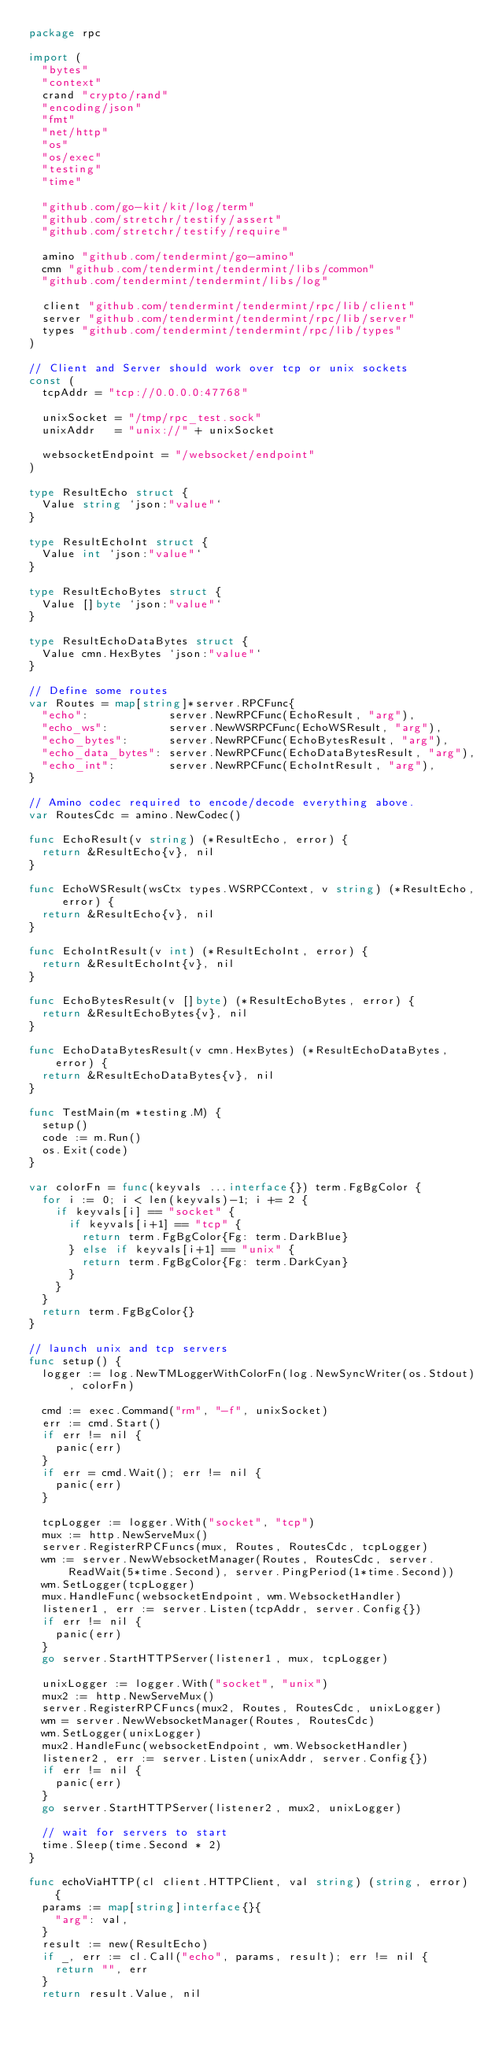<code> <loc_0><loc_0><loc_500><loc_500><_Go_>package rpc

import (
	"bytes"
	"context"
	crand "crypto/rand"
	"encoding/json"
	"fmt"
	"net/http"
	"os"
	"os/exec"
	"testing"
	"time"

	"github.com/go-kit/kit/log/term"
	"github.com/stretchr/testify/assert"
	"github.com/stretchr/testify/require"

	amino "github.com/tendermint/go-amino"
	cmn "github.com/tendermint/tendermint/libs/common"
	"github.com/tendermint/tendermint/libs/log"

	client "github.com/tendermint/tendermint/rpc/lib/client"
	server "github.com/tendermint/tendermint/rpc/lib/server"
	types "github.com/tendermint/tendermint/rpc/lib/types"
)

// Client and Server should work over tcp or unix sockets
const (
	tcpAddr = "tcp://0.0.0.0:47768"

	unixSocket = "/tmp/rpc_test.sock"
	unixAddr   = "unix://" + unixSocket

	websocketEndpoint = "/websocket/endpoint"
)

type ResultEcho struct {
	Value string `json:"value"`
}

type ResultEchoInt struct {
	Value int `json:"value"`
}

type ResultEchoBytes struct {
	Value []byte `json:"value"`
}

type ResultEchoDataBytes struct {
	Value cmn.HexBytes `json:"value"`
}

// Define some routes
var Routes = map[string]*server.RPCFunc{
	"echo":            server.NewRPCFunc(EchoResult, "arg"),
	"echo_ws":         server.NewWSRPCFunc(EchoWSResult, "arg"),
	"echo_bytes":      server.NewRPCFunc(EchoBytesResult, "arg"),
	"echo_data_bytes": server.NewRPCFunc(EchoDataBytesResult, "arg"),
	"echo_int":        server.NewRPCFunc(EchoIntResult, "arg"),
}

// Amino codec required to encode/decode everything above.
var RoutesCdc = amino.NewCodec()

func EchoResult(v string) (*ResultEcho, error) {
	return &ResultEcho{v}, nil
}

func EchoWSResult(wsCtx types.WSRPCContext, v string) (*ResultEcho, error) {
	return &ResultEcho{v}, nil
}

func EchoIntResult(v int) (*ResultEchoInt, error) {
	return &ResultEchoInt{v}, nil
}

func EchoBytesResult(v []byte) (*ResultEchoBytes, error) {
	return &ResultEchoBytes{v}, nil
}

func EchoDataBytesResult(v cmn.HexBytes) (*ResultEchoDataBytes, error) {
	return &ResultEchoDataBytes{v}, nil
}

func TestMain(m *testing.M) {
	setup()
	code := m.Run()
	os.Exit(code)
}

var colorFn = func(keyvals ...interface{}) term.FgBgColor {
	for i := 0; i < len(keyvals)-1; i += 2 {
		if keyvals[i] == "socket" {
			if keyvals[i+1] == "tcp" {
				return term.FgBgColor{Fg: term.DarkBlue}
			} else if keyvals[i+1] == "unix" {
				return term.FgBgColor{Fg: term.DarkCyan}
			}
		}
	}
	return term.FgBgColor{}
}

// launch unix and tcp servers
func setup() {
	logger := log.NewTMLoggerWithColorFn(log.NewSyncWriter(os.Stdout), colorFn)

	cmd := exec.Command("rm", "-f", unixSocket)
	err := cmd.Start()
	if err != nil {
		panic(err)
	}
	if err = cmd.Wait(); err != nil {
		panic(err)
	}

	tcpLogger := logger.With("socket", "tcp")
	mux := http.NewServeMux()
	server.RegisterRPCFuncs(mux, Routes, RoutesCdc, tcpLogger)
	wm := server.NewWebsocketManager(Routes, RoutesCdc, server.ReadWait(5*time.Second), server.PingPeriod(1*time.Second))
	wm.SetLogger(tcpLogger)
	mux.HandleFunc(websocketEndpoint, wm.WebsocketHandler)
	listener1, err := server.Listen(tcpAddr, server.Config{})
	if err != nil {
		panic(err)
	}
	go server.StartHTTPServer(listener1, mux, tcpLogger)

	unixLogger := logger.With("socket", "unix")
	mux2 := http.NewServeMux()
	server.RegisterRPCFuncs(mux2, Routes, RoutesCdc, unixLogger)
	wm = server.NewWebsocketManager(Routes, RoutesCdc)
	wm.SetLogger(unixLogger)
	mux2.HandleFunc(websocketEndpoint, wm.WebsocketHandler)
	listener2, err := server.Listen(unixAddr, server.Config{})
	if err != nil {
		panic(err)
	}
	go server.StartHTTPServer(listener2, mux2, unixLogger)

	// wait for servers to start
	time.Sleep(time.Second * 2)
}

func echoViaHTTP(cl client.HTTPClient, val string) (string, error) {
	params := map[string]interface{}{
		"arg": val,
	}
	result := new(ResultEcho)
	if _, err := cl.Call("echo", params, result); err != nil {
		return "", err
	}
	return result.Value, nil</code> 